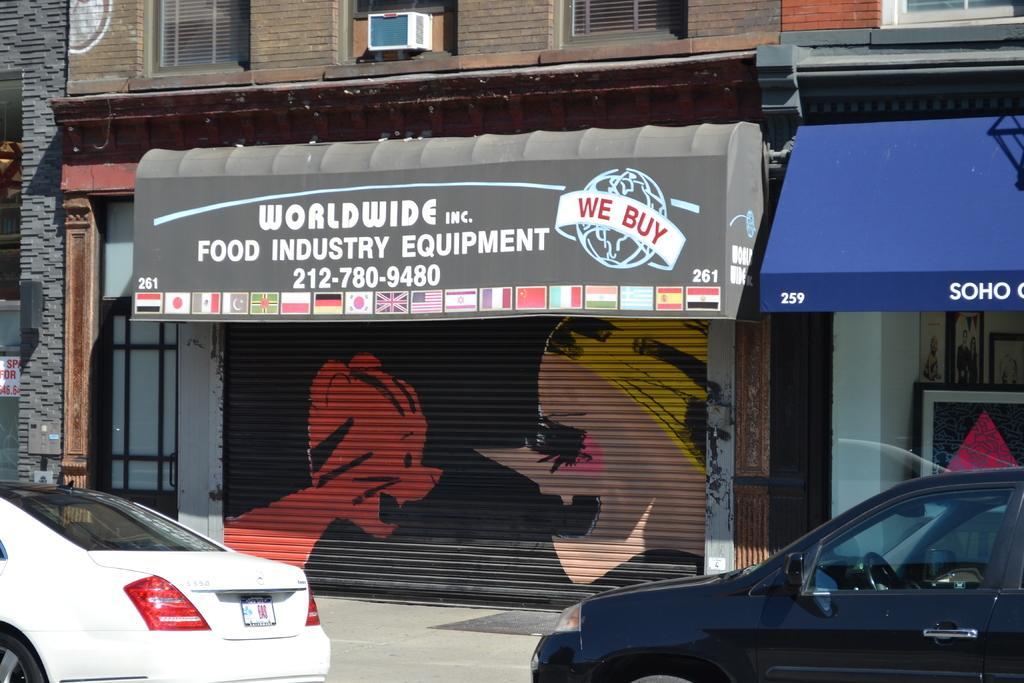Please provide a concise description of this image. In this image we can see cars parked on the road. In the background, we can see shutters, boards and the building. 